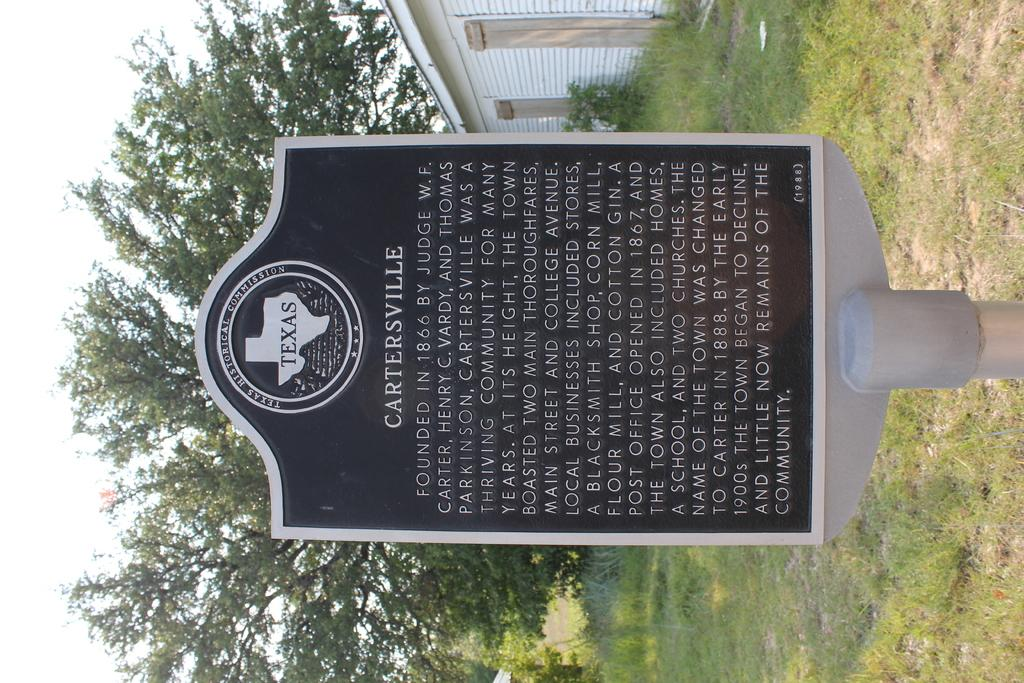What is located in the foreground of the image? There is a stone with text in the foreground of the image. What can be seen in the middle of the image? There are trees, a building, a plant, and grass in the middle of the image. What type of vegetation is present on the right side of the image? There is grass on the right side of the image. What is visible on the left side of the image? There is sky on the left side of the image. How many cows are grazing on the grass in the image? There are no cows present in the image; it features a stone with text, trees, a building, a plant, and grass. What decision does the plant make in the middle of the image? Plants do not make decisions; they are living organisms that grow and respond to their environment. 